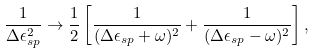Convert formula to latex. <formula><loc_0><loc_0><loc_500><loc_500>\frac { 1 } { \Delta \epsilon _ { s p } ^ { 2 } } \rightarrow \frac { 1 } { 2 } \left [ \frac { 1 } { ( \Delta \epsilon _ { s p } + \omega ) ^ { 2 } } + \frac { 1 } { ( \Delta \epsilon _ { s p } - \omega ) ^ { 2 } } \right ] ,</formula> 